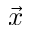<formula> <loc_0><loc_0><loc_500><loc_500>\vec { x }</formula> 